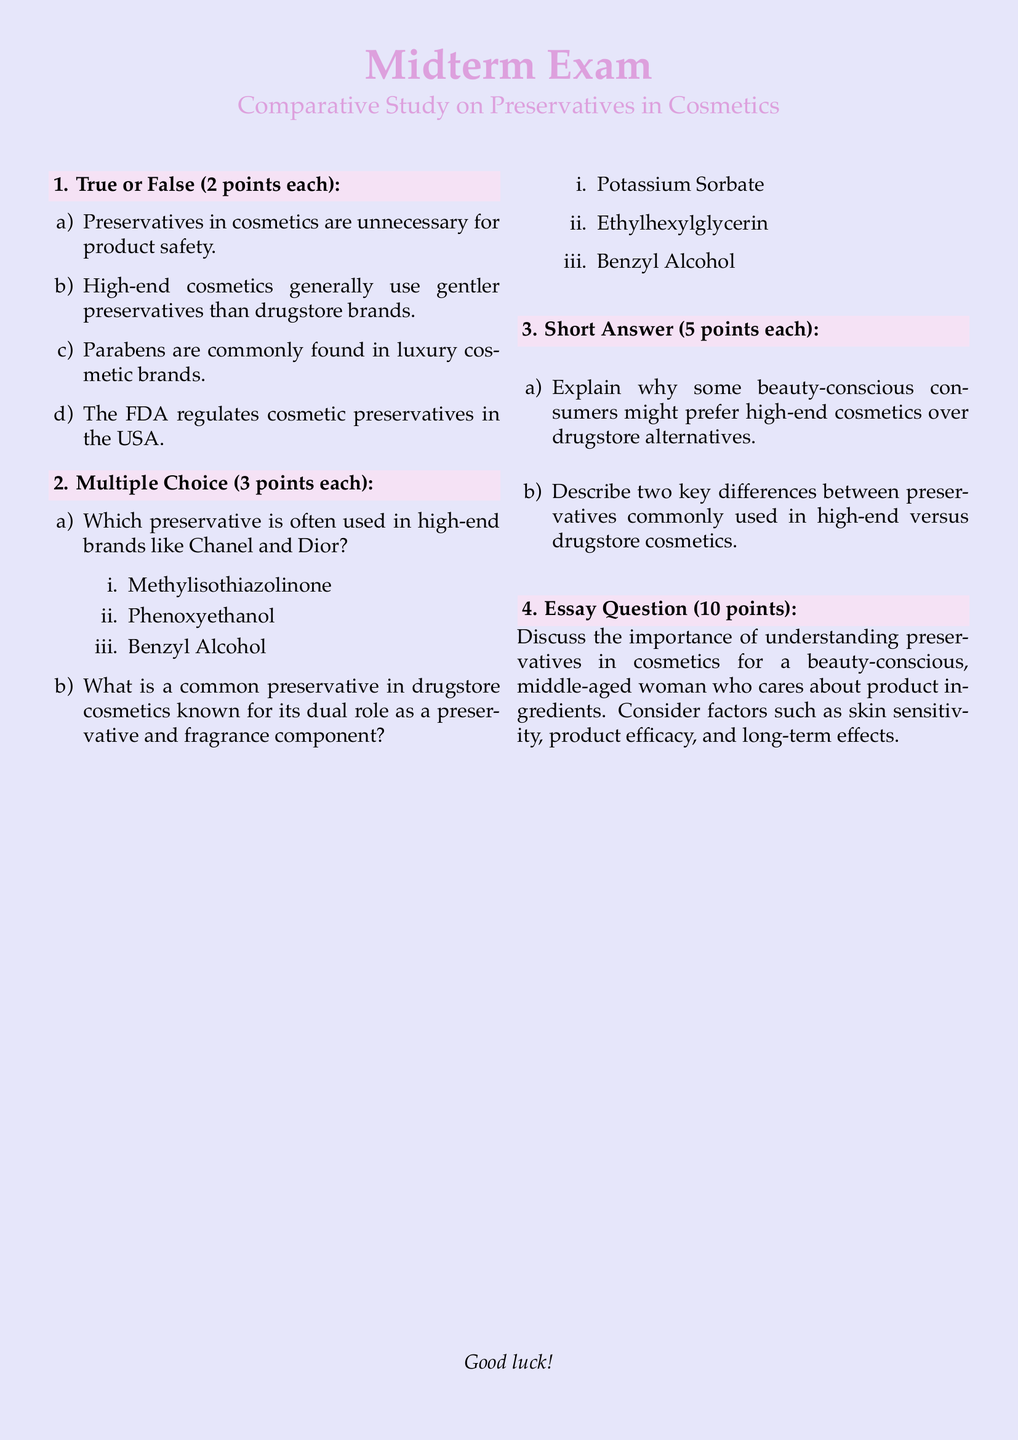What is the title of the exam? The title of the exam is mentioned at the top of the document, which is "Comparative Study on Preservatives in Cosmetics."
Answer: Comparative Study on Preservatives in Cosmetics How many points is each True or False question worth? Each True or False question is stated to be worth 2 points in the exam.
Answer: 2 points Which preservative is commonly associated with high-end brands like Chanel and Dior? The document lists Phenoxyethanol as the preservative often used in high-end brands.
Answer: Phenoxyethanol What are the two types of questions included in the exam format? The exam format includes True or False questions and Multiple Choice questions.
Answer: True or False and Multiple Choice How many points is the essay question worth? The essay question is explicitly noted to be worth 10 points in the exam.
Answer: 10 points What is one reason high-end cosmetics might be preferred by consumers? The question regarding preferences notes that beauty-conscious consumers might prefer high-end cosmetics for various reasons including ingredient quality.
Answer: Ingredient quality Which preservative is a common dual-purpose ingredient in drugstore cosmetics? The document identifies Ethylhexylglycerin as a common preservative with a dual role in drugstore products.
Answer: Ethylhexylglycerin How many key differences should be described between high-end and drugstore preservatives? The exam asks for a description of two key differences between the preservatives.
Answer: Two key differences 